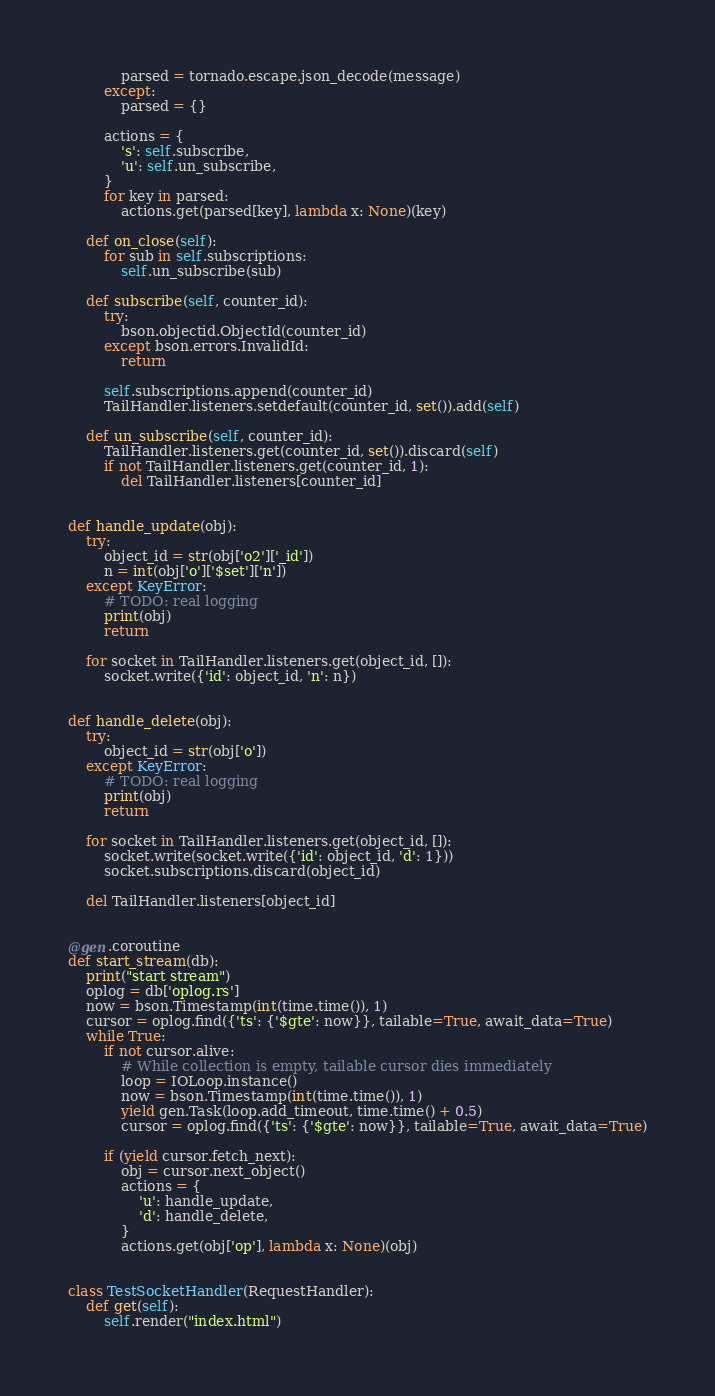<code> <loc_0><loc_0><loc_500><loc_500><_Python_>            parsed = tornado.escape.json_decode(message)
        except:
            parsed = {}

        actions = {
            's': self.subscribe,
            'u': self.un_subscribe,
        }
        for key in parsed:
            actions.get(parsed[key], lambda x: None)(key)

    def on_close(self):
        for sub in self.subscriptions:
            self.un_subscribe(sub)

    def subscribe(self, counter_id):
        try:
            bson.objectid.ObjectId(counter_id)
        except bson.errors.InvalidId:
            return

        self.subscriptions.append(counter_id)
        TailHandler.listeners.setdefault(counter_id, set()).add(self)

    def un_subscribe(self, counter_id):
        TailHandler.listeners.get(counter_id, set()).discard(self)
        if not TailHandler.listeners.get(counter_id, 1):
            del TailHandler.listeners[counter_id]


def handle_update(obj):
    try:
        object_id = str(obj['o2']['_id'])
        n = int(obj['o']['$set']['n'])
    except KeyError:
        # TODO: real logging
        print(obj)
        return

    for socket in TailHandler.listeners.get(object_id, []):
        socket.write({'id': object_id, 'n': n})


def handle_delete(obj):
    try:
        object_id = str(obj['o'])
    except KeyError:
        # TODO: real logging
        print(obj)
        return

    for socket in TailHandler.listeners.get(object_id, []):
        socket.write(socket.write({'id': object_id, 'd': 1}))
        socket.subscriptions.discard(object_id)

    del TailHandler.listeners[object_id]


@gen.coroutine
def start_stream(db):
    print("start stream")
    oplog = db['oplog.rs']
    now = bson.Timestamp(int(time.time()), 1)
    cursor = oplog.find({'ts': {'$gte': now}}, tailable=True, await_data=True)
    while True:
        if not cursor.alive:
            # While collection is empty, tailable cursor dies immediately
            loop = IOLoop.instance()
            now = bson.Timestamp(int(time.time()), 1)
            yield gen.Task(loop.add_timeout, time.time() + 0.5)
            cursor = oplog.find({'ts': {'$gte': now}}, tailable=True, await_data=True)

        if (yield cursor.fetch_next):
            obj = cursor.next_object()
            actions = {
                'u': handle_update,
                'd': handle_delete,
            }
            actions.get(obj['op'], lambda x: None)(obj)


class TestSocketHandler(RequestHandler):
    def get(self):
        self.render("index.html")
</code> 